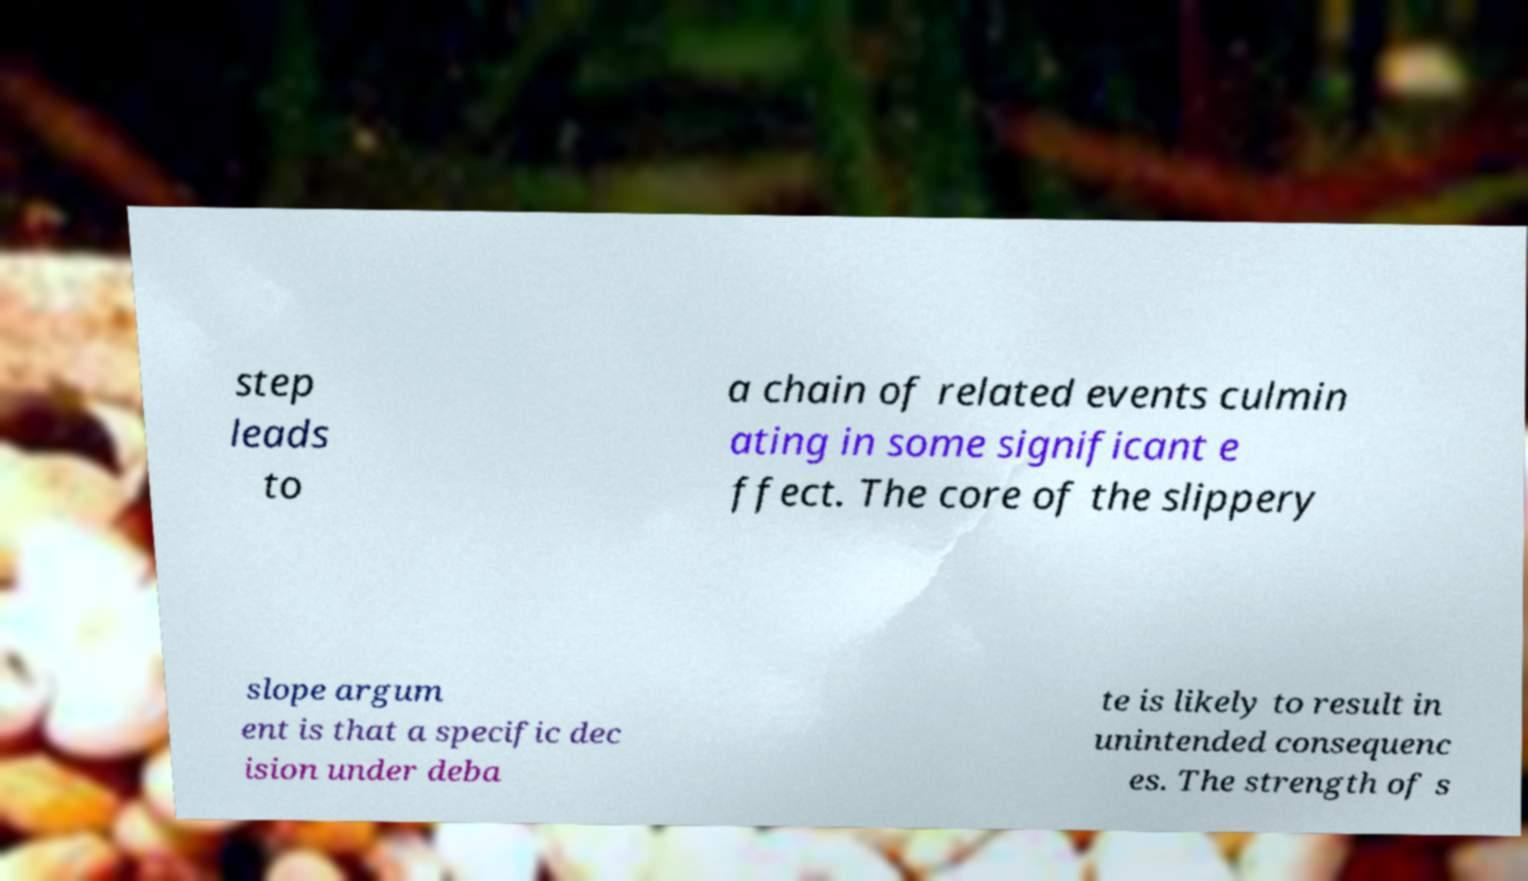There's text embedded in this image that I need extracted. Can you transcribe it verbatim? step leads to a chain of related events culmin ating in some significant e ffect. The core of the slippery slope argum ent is that a specific dec ision under deba te is likely to result in unintended consequenc es. The strength of s 